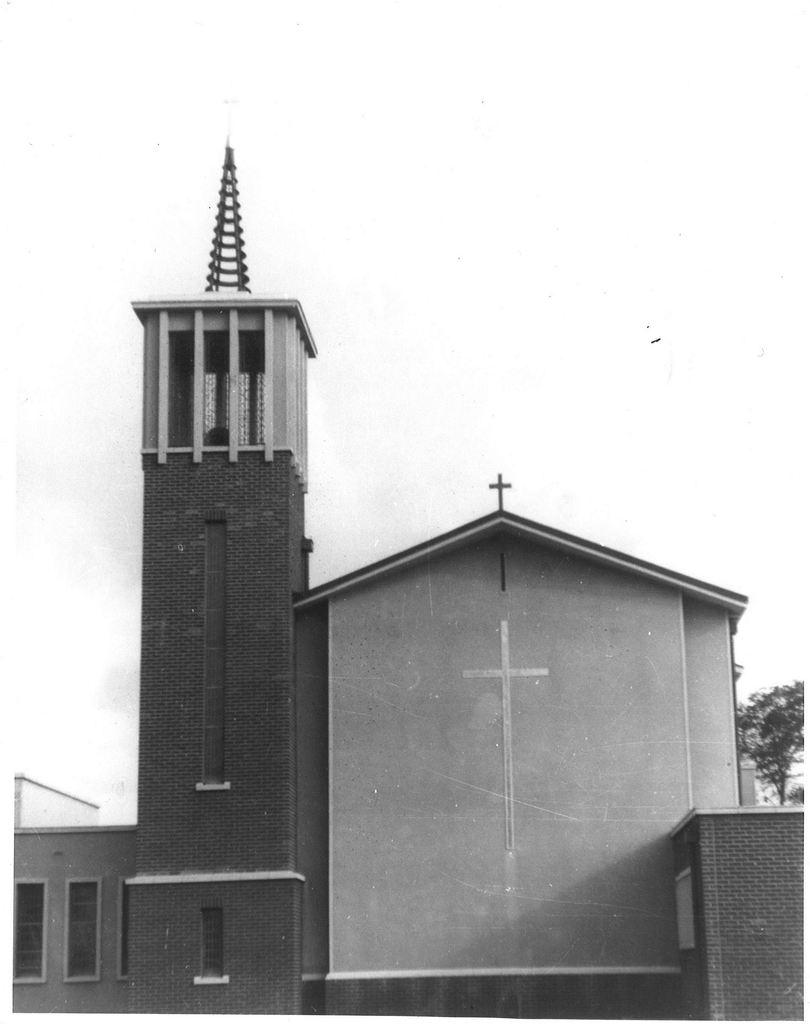What type of structure is in the image? There is a building in the image. What feature can be seen on the building? The building has windows. What symbol is above the building? There is a cross symbol above the building. What type of vegetation is on the right side of the image? There is a tree on the right side of the image. What type of tent can be seen in the image? There is no tent present in the image; it features a building with a cross symbol above it and a tree on the right side. How many ornaments are hanging from the tree in the image? There is no mention of ornaments in the image; it only shows a tree on the right side. 